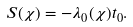Convert formula to latex. <formula><loc_0><loc_0><loc_500><loc_500>S ( \chi ) = - \lambda _ { 0 } ( \chi ) t _ { 0 } .</formula> 